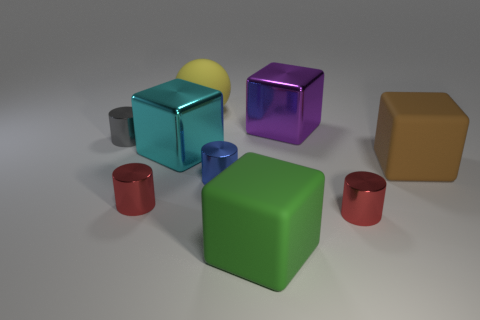What color is the other large block that is the same material as the big brown block?
Ensure brevity in your answer.  Green. There is a metallic cylinder that is behind the large metal cube in front of the metal cube on the right side of the large cyan shiny block; what is its color?
Your response must be concise. Gray. Do the blue metal thing and the rubber object in front of the brown rubber cube have the same size?
Provide a short and direct response. No. What number of things are either big matte blocks in front of the large brown cube or tiny objects on the left side of the ball?
Your answer should be compact. 3. What shape is the cyan shiny thing that is the same size as the purple cube?
Give a very brief answer. Cube. There is a small object behind the object on the right side of the small metal cylinder right of the big green matte thing; what shape is it?
Offer a very short reply. Cylinder. Are there an equal number of big brown cubes left of the matte sphere and large gray metal cubes?
Make the answer very short. Yes. Does the yellow matte ball have the same size as the gray thing?
Provide a short and direct response. No. How many metallic things are green cubes or big objects?
Your answer should be compact. 2. What material is the brown thing that is the same size as the purple metal thing?
Your answer should be very brief. Rubber. 